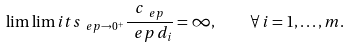Convert formula to latex. <formula><loc_0><loc_0><loc_500><loc_500>\lim \lim i t s _ { \ e p \to 0 ^ { + } } \frac { c _ { \ e p } } { \ e p \, d _ { i } } = \infty , \quad \forall \, i = 1 , \dots , m .</formula> 